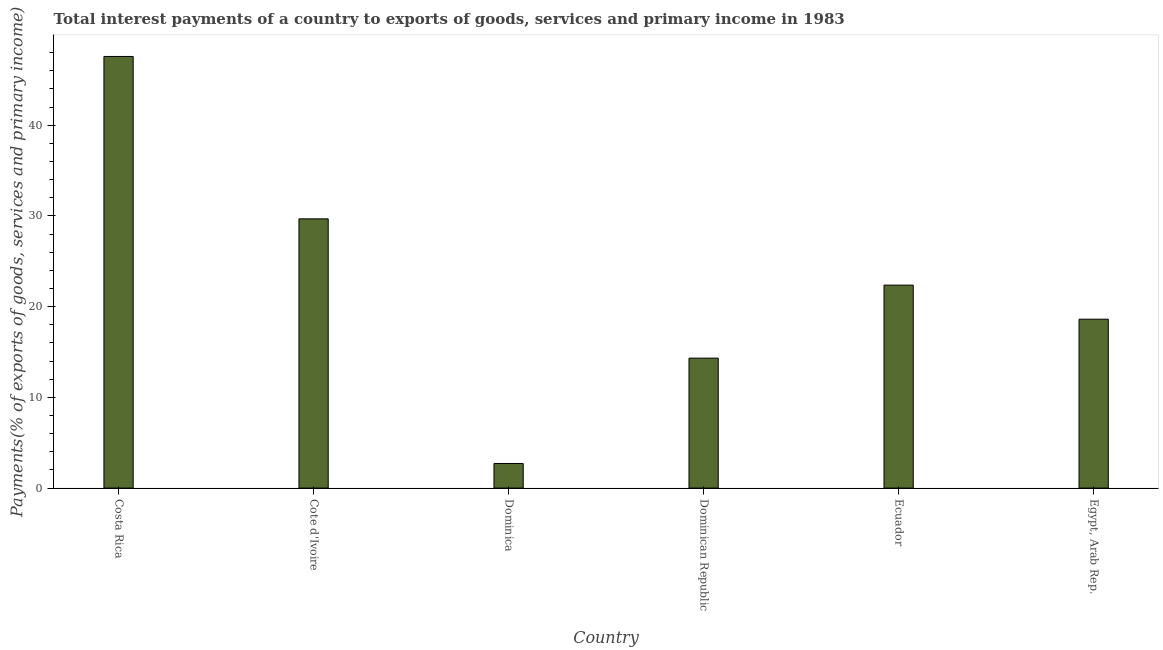Does the graph contain grids?
Your response must be concise. No. What is the title of the graph?
Make the answer very short. Total interest payments of a country to exports of goods, services and primary income in 1983. What is the label or title of the Y-axis?
Provide a succinct answer. Payments(% of exports of goods, services and primary income). What is the total interest payments on external debt in Costa Rica?
Offer a very short reply. 47.58. Across all countries, what is the maximum total interest payments on external debt?
Provide a succinct answer. 47.58. Across all countries, what is the minimum total interest payments on external debt?
Provide a short and direct response. 2.71. In which country was the total interest payments on external debt maximum?
Provide a succinct answer. Costa Rica. In which country was the total interest payments on external debt minimum?
Offer a very short reply. Dominica. What is the sum of the total interest payments on external debt?
Keep it short and to the point. 135.28. What is the difference between the total interest payments on external debt in Ecuador and Egypt, Arab Rep.?
Keep it short and to the point. 3.76. What is the average total interest payments on external debt per country?
Keep it short and to the point. 22.55. What is the median total interest payments on external debt?
Provide a short and direct response. 20.5. What is the ratio of the total interest payments on external debt in Costa Rica to that in Cote d'Ivoire?
Offer a very short reply. 1.6. Is the difference between the total interest payments on external debt in Cote d'Ivoire and Dominican Republic greater than the difference between any two countries?
Give a very brief answer. No. What is the difference between the highest and the second highest total interest payments on external debt?
Give a very brief answer. 17.9. What is the difference between the highest and the lowest total interest payments on external debt?
Provide a short and direct response. 44.87. In how many countries, is the total interest payments on external debt greater than the average total interest payments on external debt taken over all countries?
Your answer should be compact. 2. How many countries are there in the graph?
Offer a very short reply. 6. What is the difference between two consecutive major ticks on the Y-axis?
Provide a succinct answer. 10. Are the values on the major ticks of Y-axis written in scientific E-notation?
Keep it short and to the point. No. What is the Payments(% of exports of goods, services and primary income) of Costa Rica?
Your response must be concise. 47.58. What is the Payments(% of exports of goods, services and primary income) in Cote d'Ivoire?
Provide a short and direct response. 29.68. What is the Payments(% of exports of goods, services and primary income) in Dominica?
Keep it short and to the point. 2.71. What is the Payments(% of exports of goods, services and primary income) in Dominican Republic?
Keep it short and to the point. 14.32. What is the Payments(% of exports of goods, services and primary income) of Ecuador?
Keep it short and to the point. 22.37. What is the Payments(% of exports of goods, services and primary income) in Egypt, Arab Rep.?
Offer a very short reply. 18.62. What is the difference between the Payments(% of exports of goods, services and primary income) in Costa Rica and Cote d'Ivoire?
Offer a terse response. 17.9. What is the difference between the Payments(% of exports of goods, services and primary income) in Costa Rica and Dominica?
Provide a succinct answer. 44.87. What is the difference between the Payments(% of exports of goods, services and primary income) in Costa Rica and Dominican Republic?
Your answer should be compact. 33.25. What is the difference between the Payments(% of exports of goods, services and primary income) in Costa Rica and Ecuador?
Provide a short and direct response. 25.2. What is the difference between the Payments(% of exports of goods, services and primary income) in Costa Rica and Egypt, Arab Rep.?
Your response must be concise. 28.96. What is the difference between the Payments(% of exports of goods, services and primary income) in Cote d'Ivoire and Dominica?
Provide a succinct answer. 26.97. What is the difference between the Payments(% of exports of goods, services and primary income) in Cote d'Ivoire and Dominican Republic?
Ensure brevity in your answer.  15.35. What is the difference between the Payments(% of exports of goods, services and primary income) in Cote d'Ivoire and Ecuador?
Offer a very short reply. 7.3. What is the difference between the Payments(% of exports of goods, services and primary income) in Cote d'Ivoire and Egypt, Arab Rep.?
Your answer should be very brief. 11.06. What is the difference between the Payments(% of exports of goods, services and primary income) in Dominica and Dominican Republic?
Your response must be concise. -11.61. What is the difference between the Payments(% of exports of goods, services and primary income) in Dominica and Ecuador?
Keep it short and to the point. -19.66. What is the difference between the Payments(% of exports of goods, services and primary income) in Dominica and Egypt, Arab Rep.?
Keep it short and to the point. -15.91. What is the difference between the Payments(% of exports of goods, services and primary income) in Dominican Republic and Ecuador?
Your answer should be very brief. -8.05. What is the difference between the Payments(% of exports of goods, services and primary income) in Dominican Republic and Egypt, Arab Rep.?
Your answer should be compact. -4.29. What is the difference between the Payments(% of exports of goods, services and primary income) in Ecuador and Egypt, Arab Rep.?
Give a very brief answer. 3.76. What is the ratio of the Payments(% of exports of goods, services and primary income) in Costa Rica to that in Cote d'Ivoire?
Give a very brief answer. 1.6. What is the ratio of the Payments(% of exports of goods, services and primary income) in Costa Rica to that in Dominica?
Your answer should be very brief. 17.55. What is the ratio of the Payments(% of exports of goods, services and primary income) in Costa Rica to that in Dominican Republic?
Offer a terse response. 3.32. What is the ratio of the Payments(% of exports of goods, services and primary income) in Costa Rica to that in Ecuador?
Provide a succinct answer. 2.13. What is the ratio of the Payments(% of exports of goods, services and primary income) in Costa Rica to that in Egypt, Arab Rep.?
Your answer should be compact. 2.56. What is the ratio of the Payments(% of exports of goods, services and primary income) in Cote d'Ivoire to that in Dominica?
Make the answer very short. 10.95. What is the ratio of the Payments(% of exports of goods, services and primary income) in Cote d'Ivoire to that in Dominican Republic?
Make the answer very short. 2.07. What is the ratio of the Payments(% of exports of goods, services and primary income) in Cote d'Ivoire to that in Ecuador?
Provide a short and direct response. 1.33. What is the ratio of the Payments(% of exports of goods, services and primary income) in Cote d'Ivoire to that in Egypt, Arab Rep.?
Your answer should be very brief. 1.59. What is the ratio of the Payments(% of exports of goods, services and primary income) in Dominica to that in Dominican Republic?
Ensure brevity in your answer.  0.19. What is the ratio of the Payments(% of exports of goods, services and primary income) in Dominica to that in Ecuador?
Your response must be concise. 0.12. What is the ratio of the Payments(% of exports of goods, services and primary income) in Dominica to that in Egypt, Arab Rep.?
Keep it short and to the point. 0.15. What is the ratio of the Payments(% of exports of goods, services and primary income) in Dominican Republic to that in Ecuador?
Give a very brief answer. 0.64. What is the ratio of the Payments(% of exports of goods, services and primary income) in Dominican Republic to that in Egypt, Arab Rep.?
Your answer should be very brief. 0.77. What is the ratio of the Payments(% of exports of goods, services and primary income) in Ecuador to that in Egypt, Arab Rep.?
Keep it short and to the point. 1.2. 